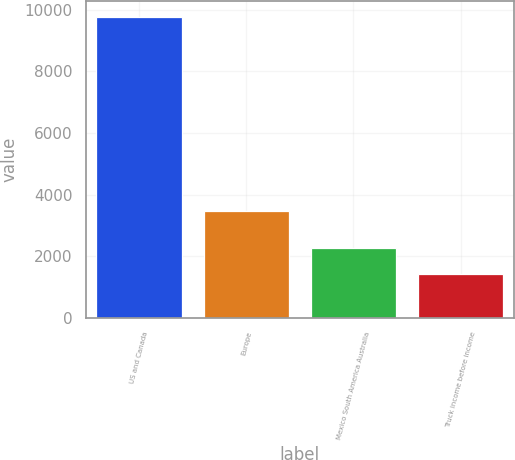<chart> <loc_0><loc_0><loc_500><loc_500><bar_chart><fcel>US and Canada<fcel>Europe<fcel>Mexico South America Australia<fcel>Truck income before income<nl><fcel>9774.3<fcel>3472.1<fcel>2273.7<fcel>1440.3<nl></chart> 